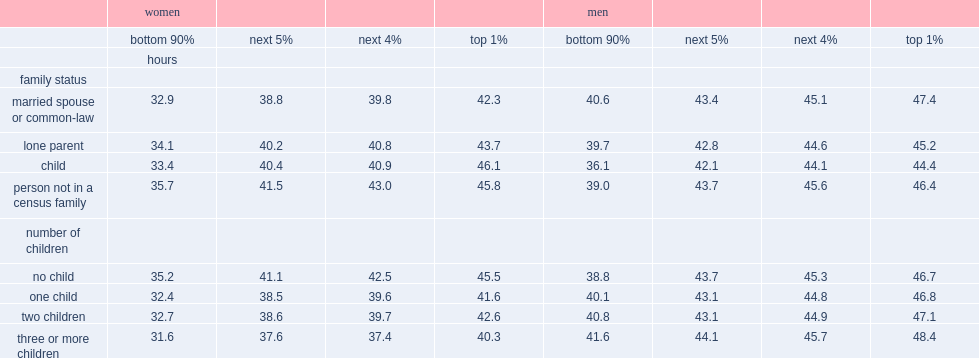How many hours did women in the top1% who were living alone or with non-family members work and their male counterparts respectively? 45.8 46.4. How many hours did women in the top 1% who were married or in a common-law relationship work? 42.3. What was the average time(hours)did women in the top 1% who had one or two children work? 42.1. 